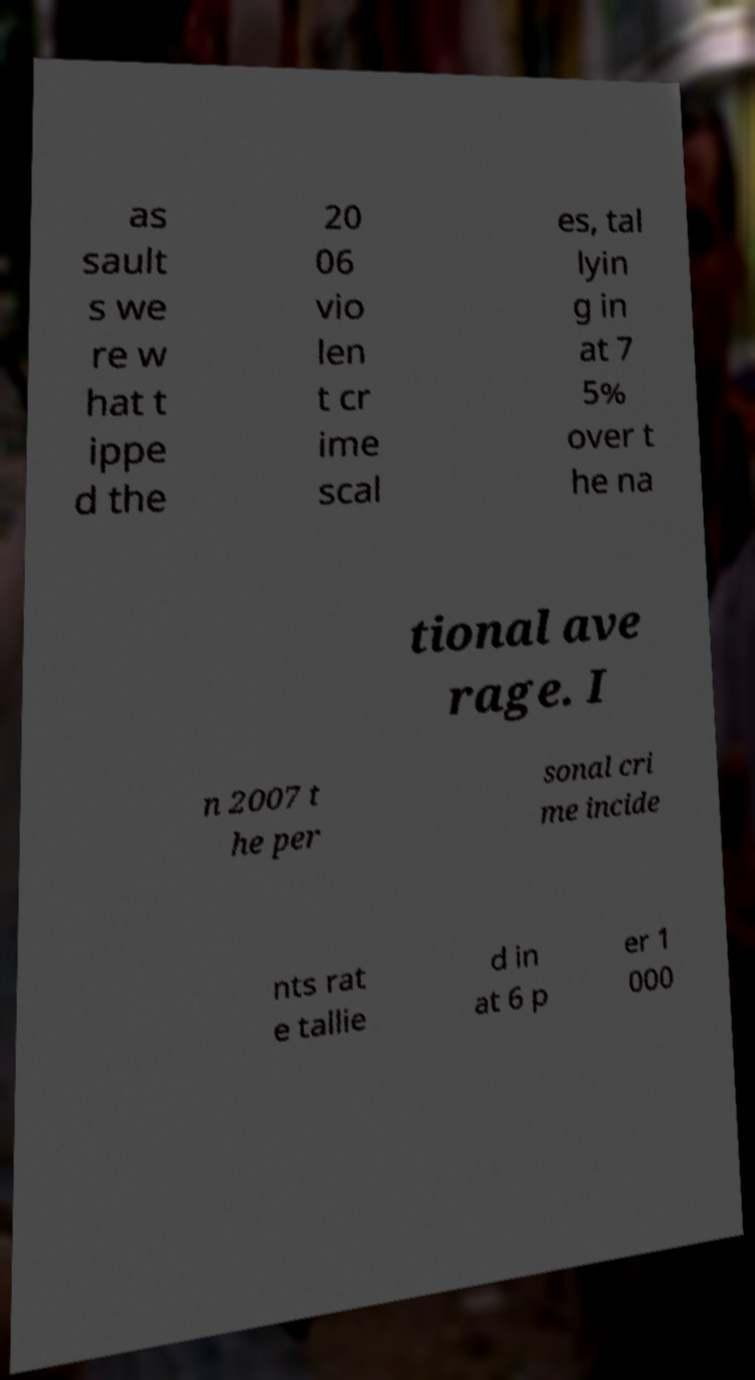For documentation purposes, I need the text within this image transcribed. Could you provide that? as sault s we re w hat t ippe d the 20 06 vio len t cr ime scal es, tal lyin g in at 7 5% over t he na tional ave rage. I n 2007 t he per sonal cri me incide nts rat e tallie d in at 6 p er 1 000 